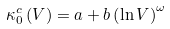Convert formula to latex. <formula><loc_0><loc_0><loc_500><loc_500>\kappa _ { 0 } ^ { c } \left ( V \right ) = a + b \left ( \ln V \right ) ^ { \omega }</formula> 